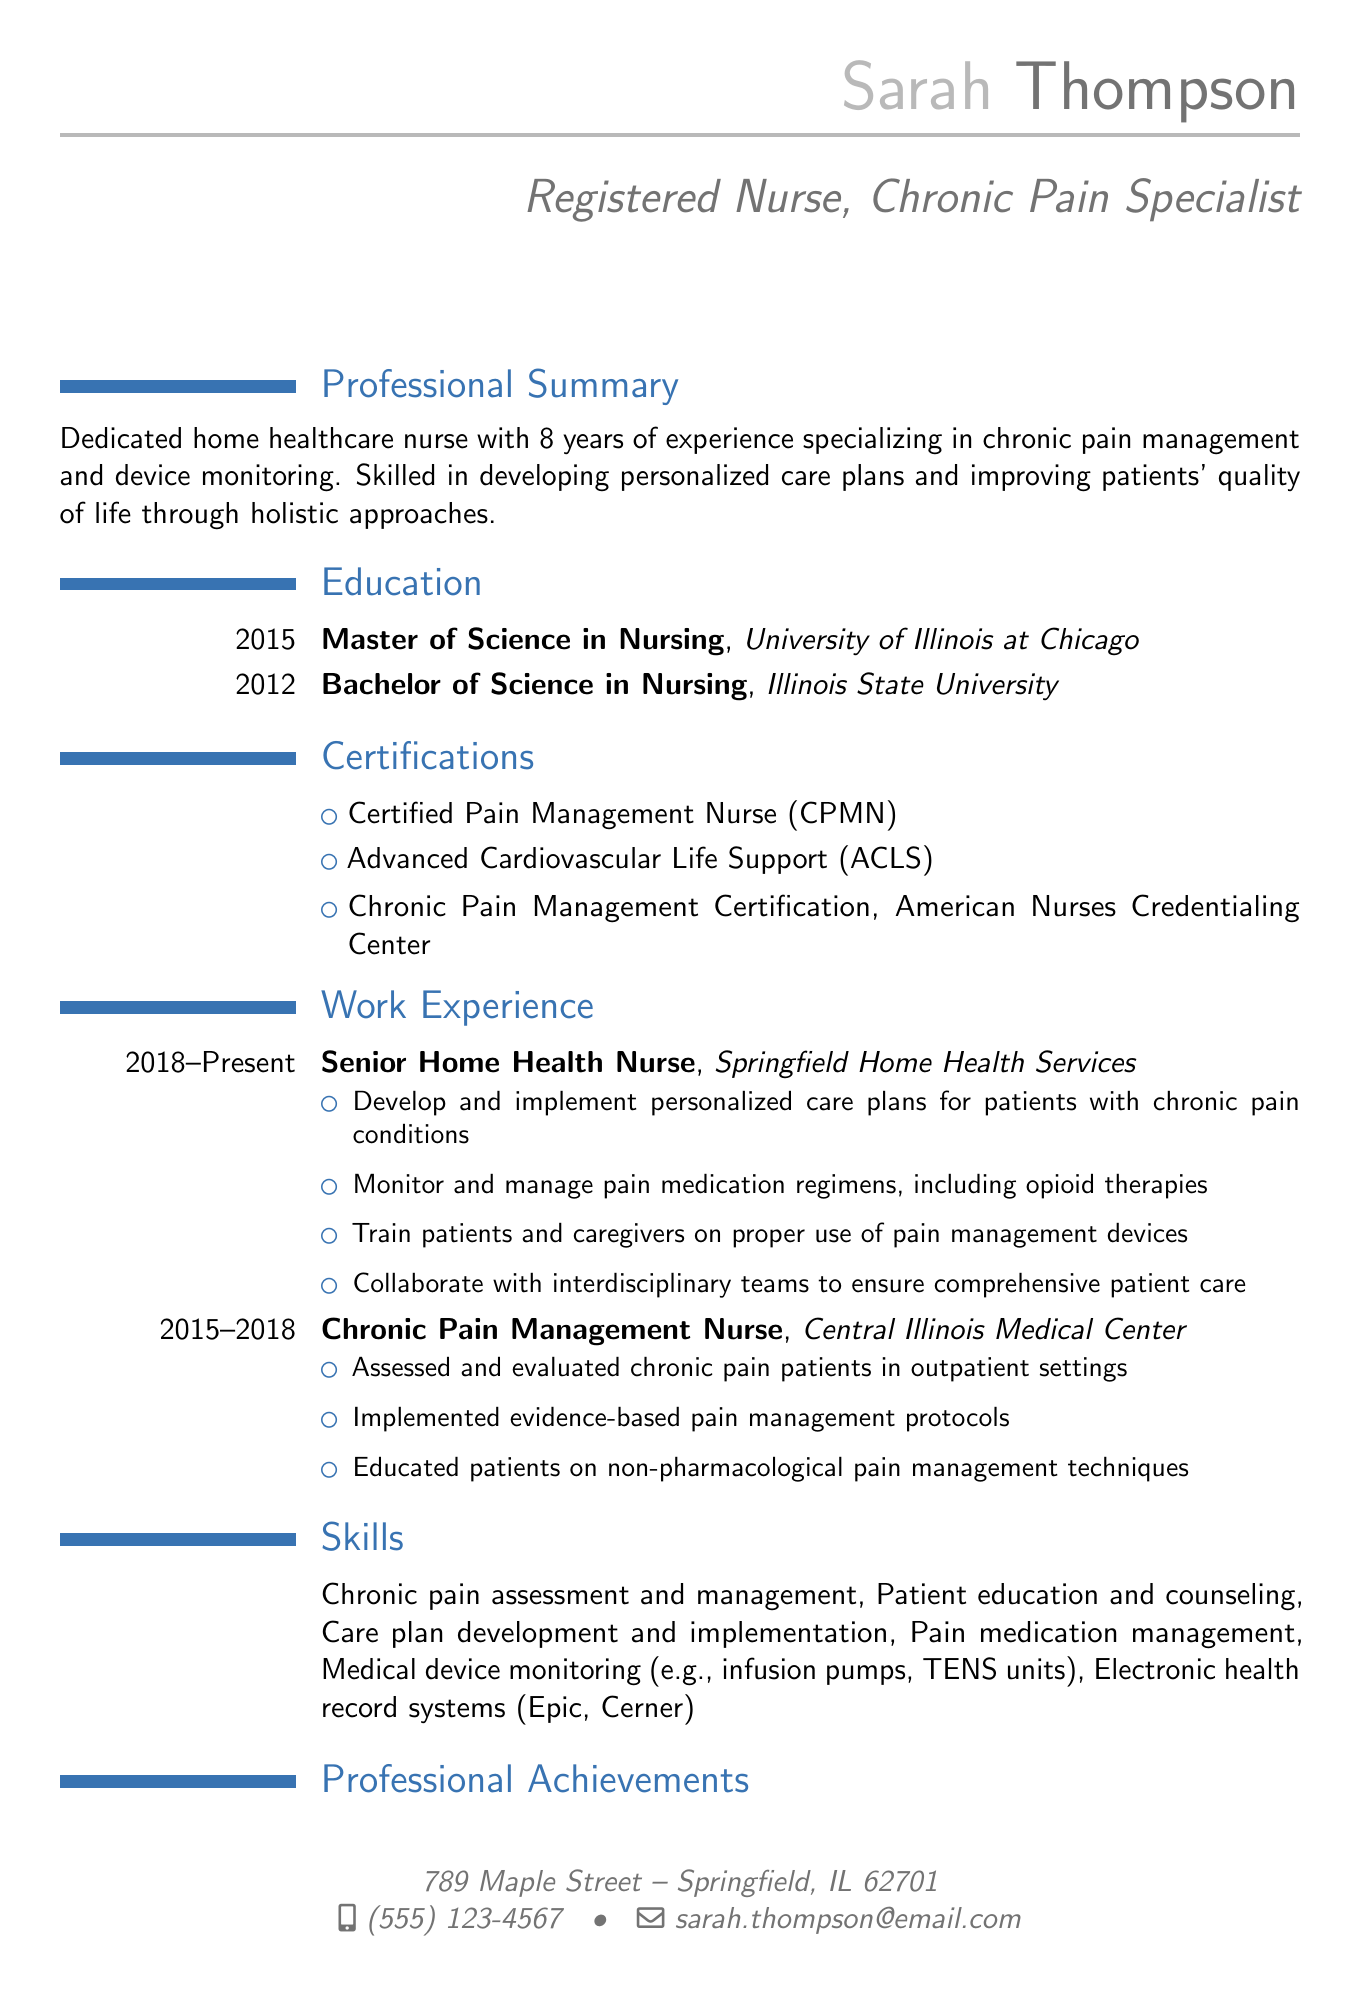What is the name of the nurse? The name of the nurse is mentioned in the personal information section of the document.
Answer: Sarah Thompson What is the highest degree obtained? The highest degree is listed in the education section of the document.
Answer: Master of Science in Nursing What certification indicates expertise in pain management? The certifications section includes specific designations showing expertise.
Answer: Certified Pain Management Nurse (CPMN) In which year did Sarah complete her Bachelor’s degree? The year of completion for the Bachelor's degree is noted in the education section.
Answer: 2012 What is the duration of Sarah's current position? The document specifies the period during which she has held her current job role.
Answer: 2018 - Present Which healthcare facility employed her as a Chronic Pain Management Nurse? This information can be found in the work experience section of the document.
Answer: Central Illinois Medical Center What percentage did hospital readmission rates reduce by? This figure is found in the professional achievements section indicating Sarah's impact.
Answer: 25% What type of patients does she develop personalized care plans for? The document specifies the target patient demographic in her work responsibilities.
Answer: Patients with chronic pain conditions How long has Sarah been working in home healthcare? By reviewing her total work experience listed, you can ascertain her duration in the field.
Answer: 8 years 